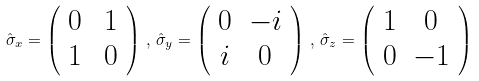Convert formula to latex. <formula><loc_0><loc_0><loc_500><loc_500>\hat { \sigma } _ { x } = \left ( \begin{array} { c c } 0 & \, 1 \\ 1 & \, 0 \end{array} \right ) \, , \, \hat { \sigma } _ { y } = \left ( \begin{array} { c c } 0 & - i \\ i & 0 \end{array} \right ) \, , \, \hat { \sigma } _ { z } = \left ( \begin{array} { c c } 1 & 0 \\ 0 & - 1 \end{array} \right )</formula> 